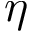Convert formula to latex. <formula><loc_0><loc_0><loc_500><loc_500>\eta</formula> 